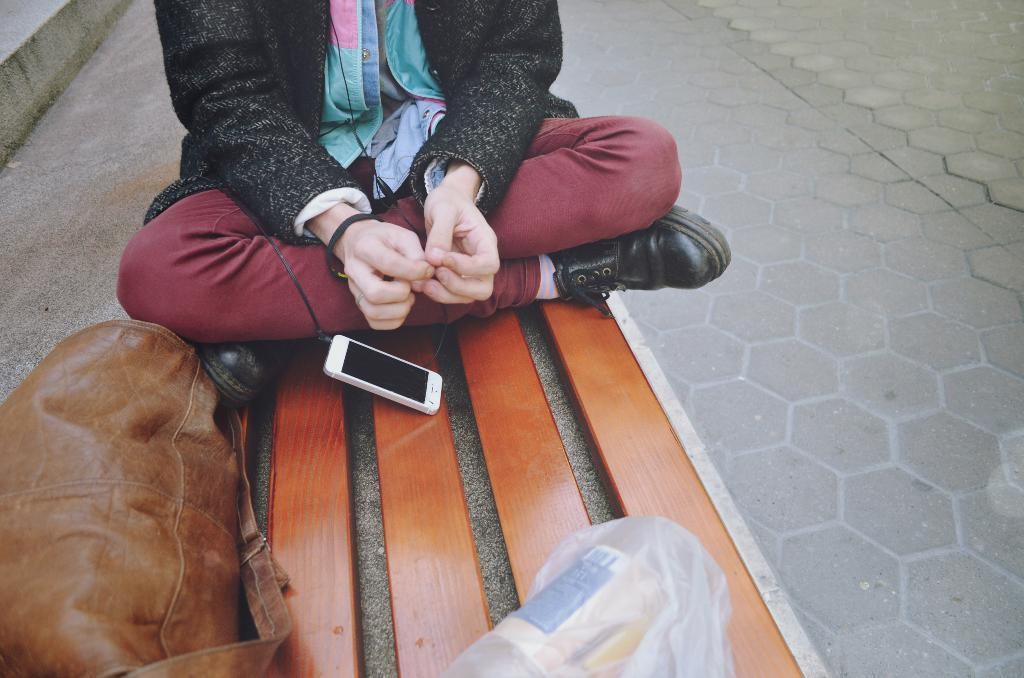What is the person in the image sitting on? The person is sitting on a wooden surface in the image. What electronic device can be seen in the image? There is a mobile phone in the image. What type of personal item is present in the image? There is a bag in the image. What is covering the mobile phone? There is a cover in the image. What type of ground surface is visible on the right side of the image? There is a pavement on the right side of the image. What architectural feature is present on the left side of the image? There are steps on the left side of the image. Is the person in the image showing their emotions through rain? There is no rain present in the image, and emotions are not shown through rain. 